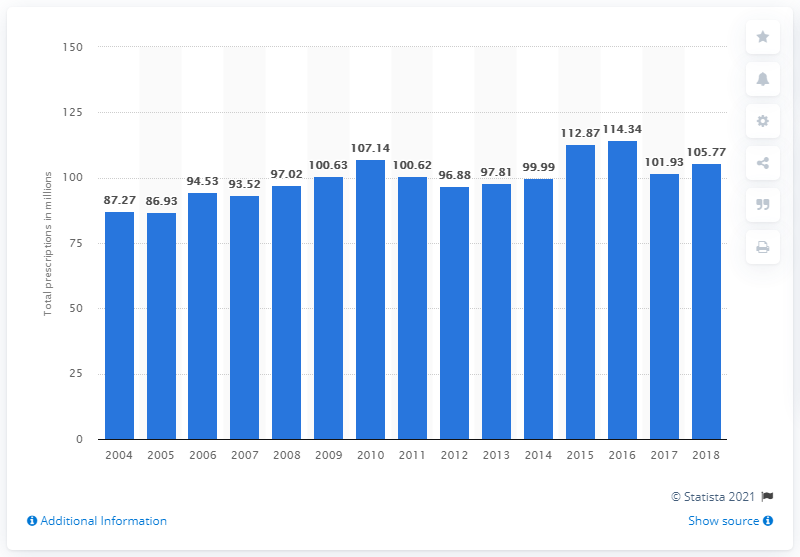Point out several critical features in this image. In 2004, a total of 87.27 prescriptions for levothyroxine were filled. In 2004, there were 100,630 prescriptions for levothyroxine. 